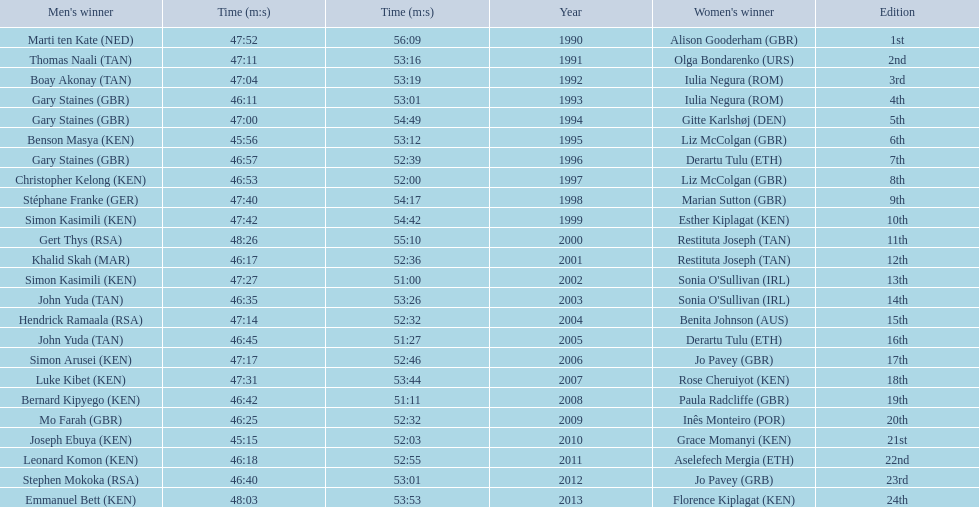What place did sonia o'sullivan finish in 2003? 14th. How long did it take her to finish? 53:26. 